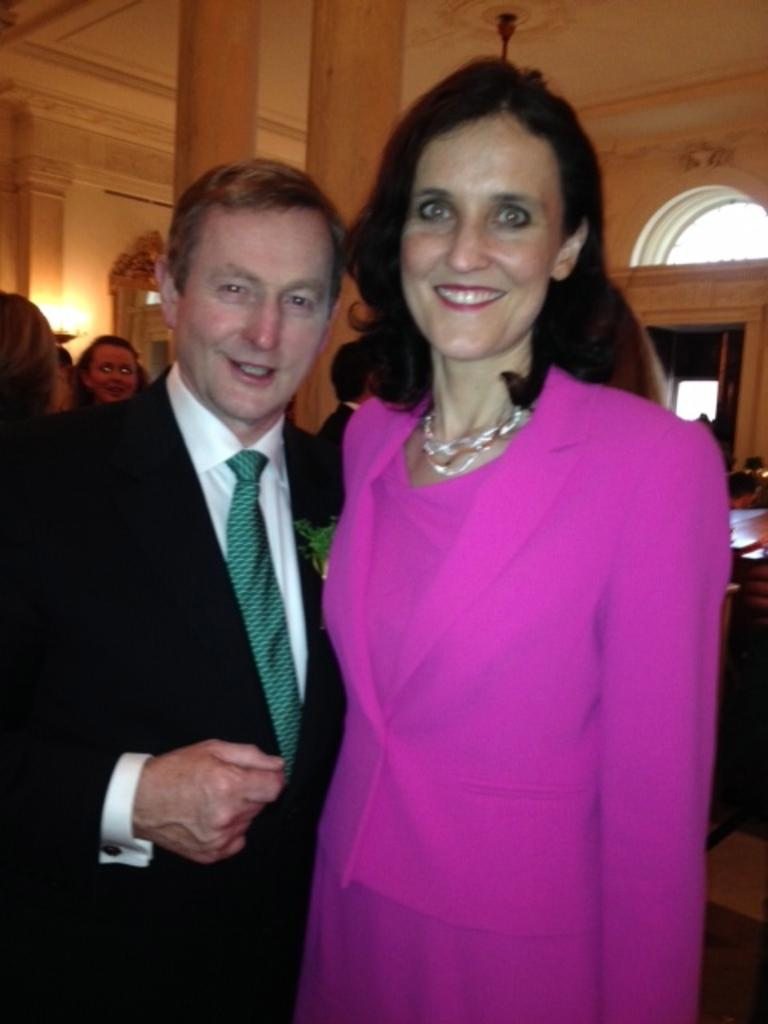What can be seen in the image? There are people standing in the image. Where are the people standing? The people are standing on the floor. What can be seen in the background of the image? There are electric lights and a ceiling fan in the background of the image. What advice is the person on the left giving to the person on the right in the image? There is no indication in the image that any advice is being given, as the people's expressions and body language do not suggest a conversation. 